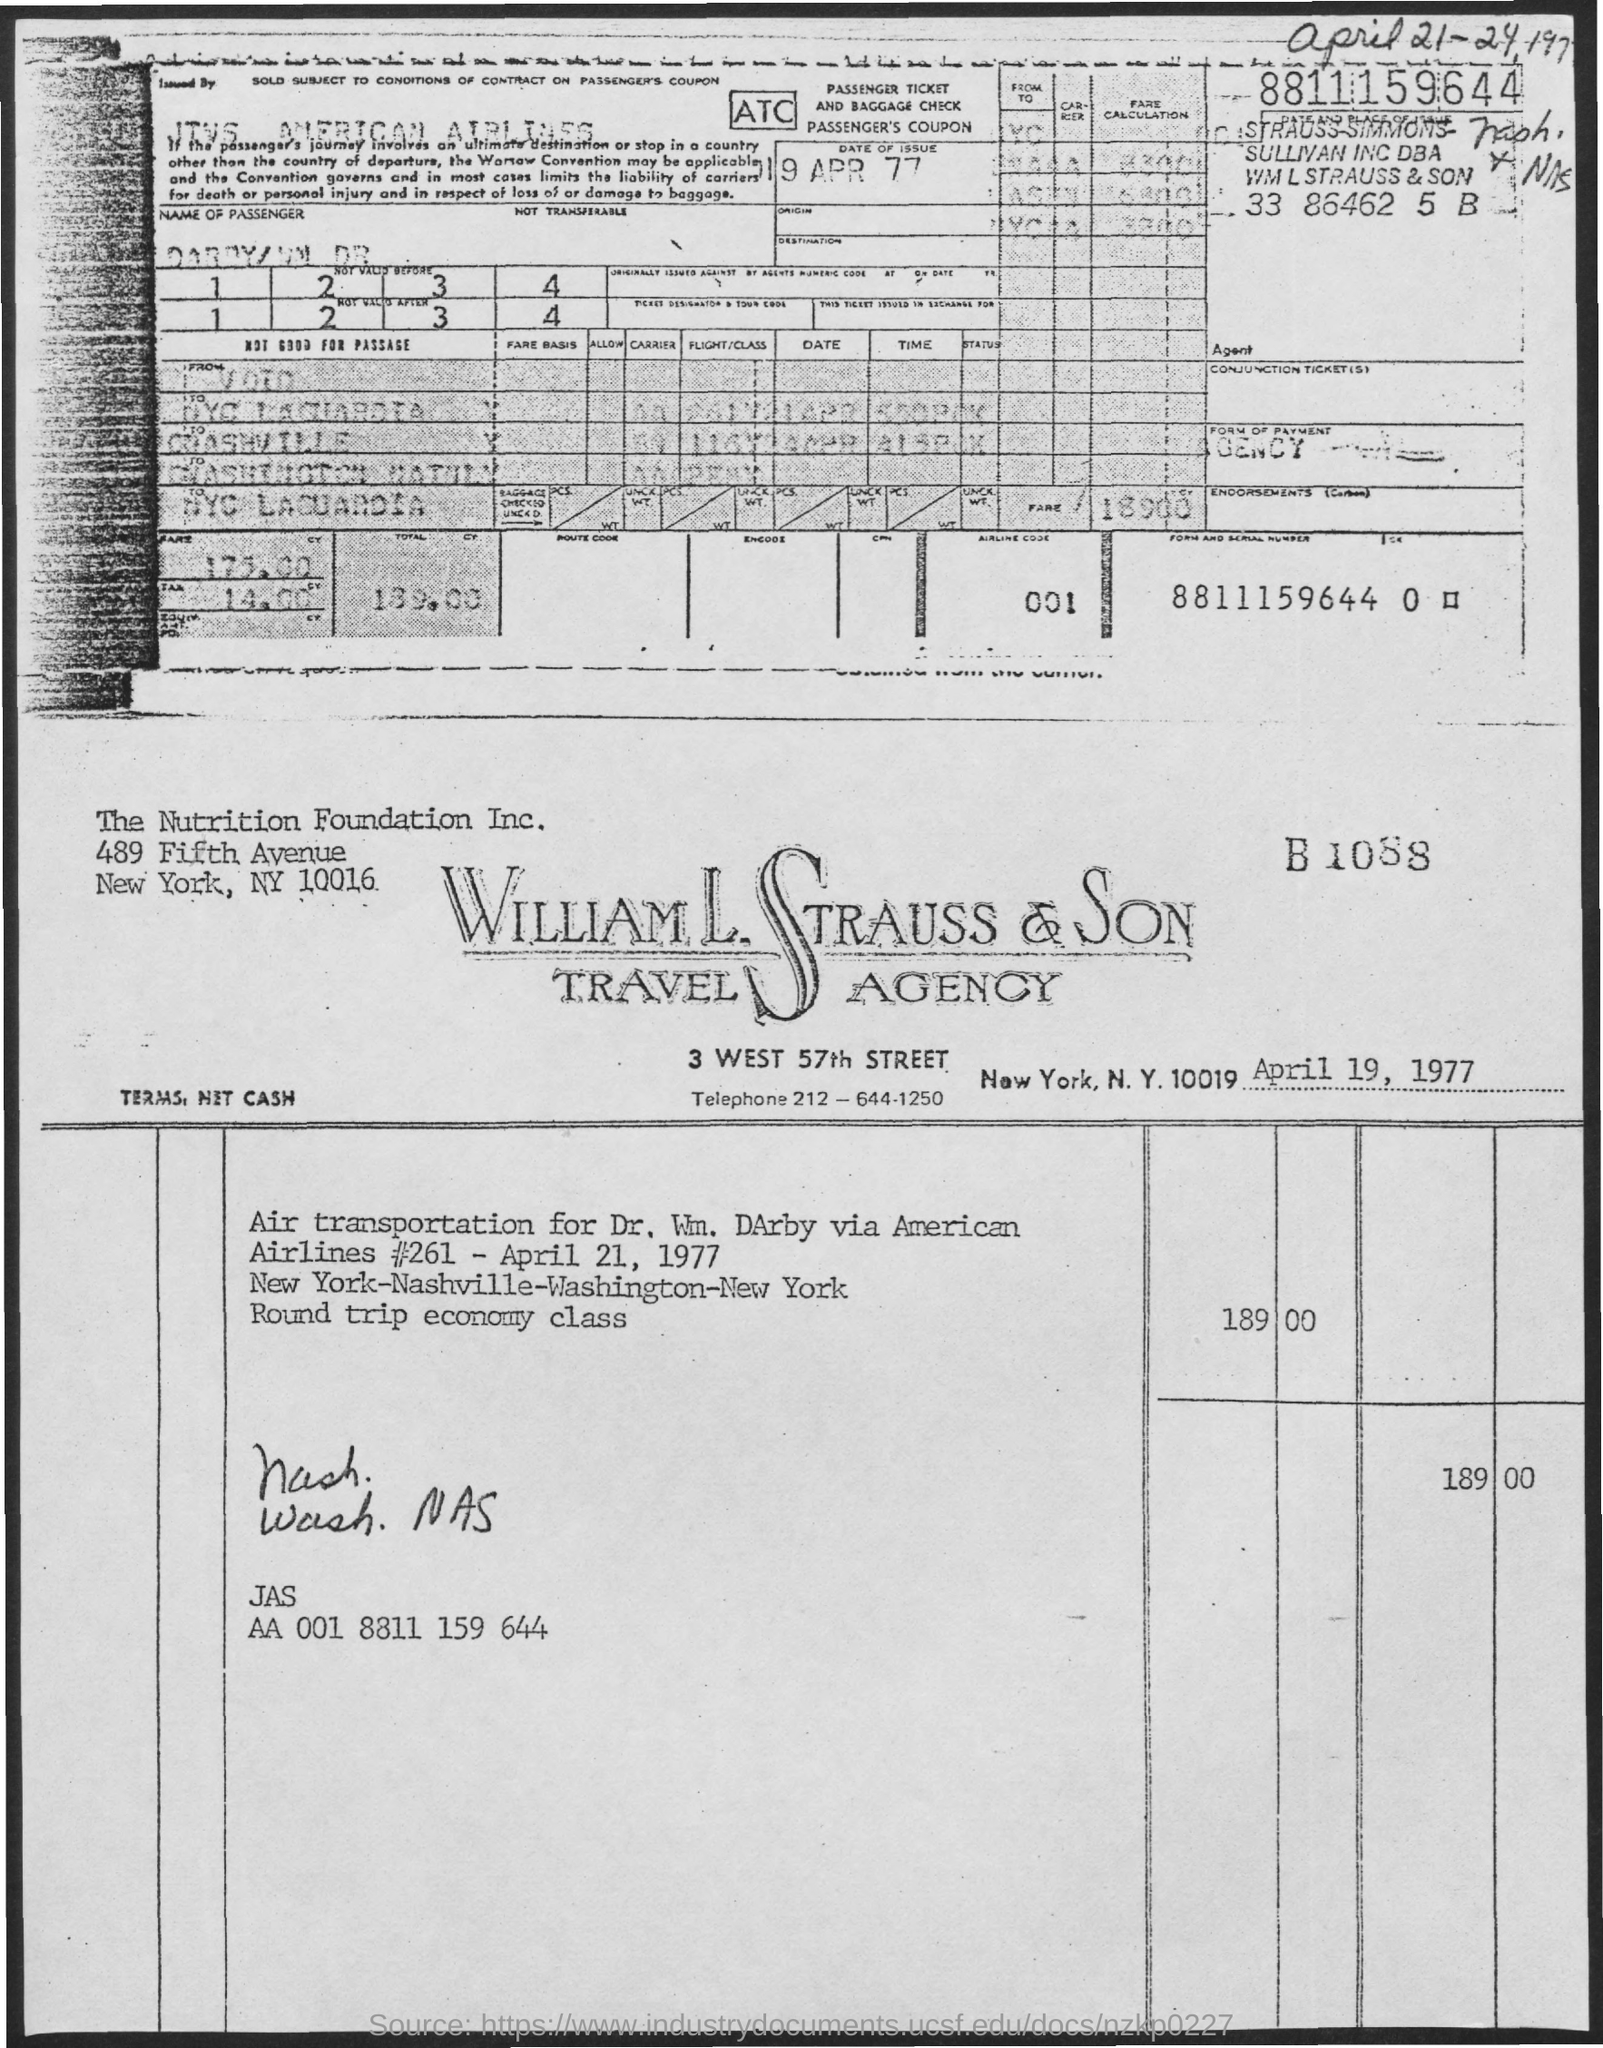When is the invoice dated?
Give a very brief answer. April 19, 1977. Which type of class is mentioned for airlines?
Give a very brief answer. Economy class. What is cost on invoice?
Your answer should be very brief. 189.00. 